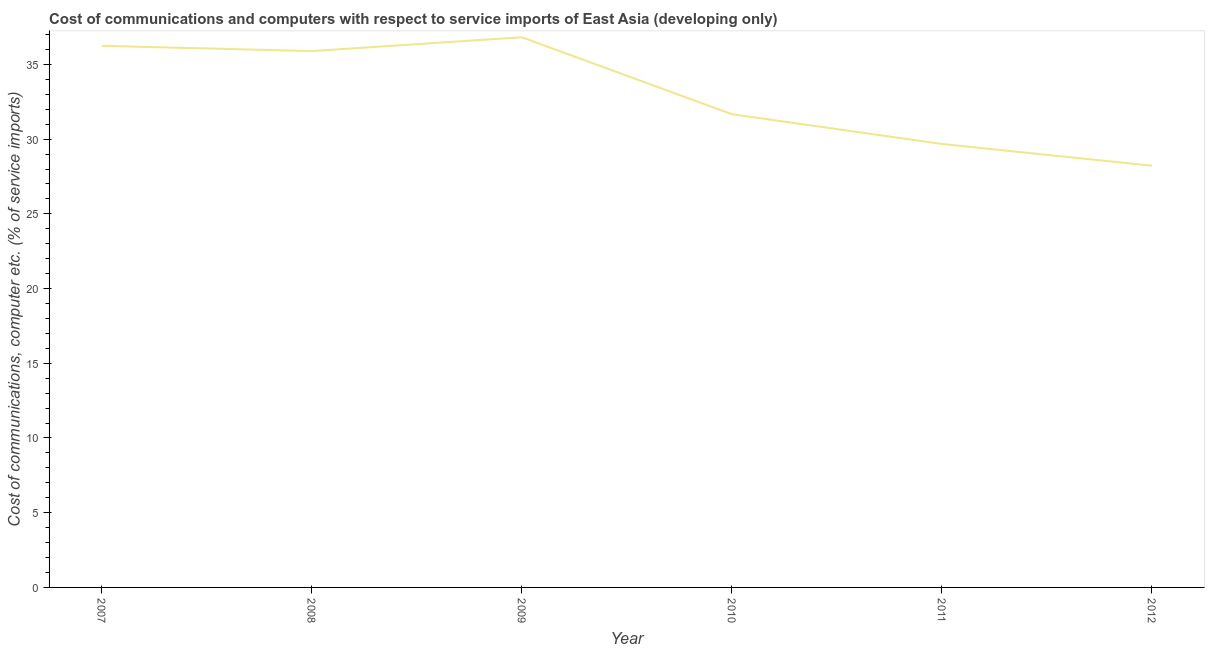What is the cost of communications and computer in 2008?
Ensure brevity in your answer.  35.89. Across all years, what is the maximum cost of communications and computer?
Offer a very short reply. 36.82. Across all years, what is the minimum cost of communications and computer?
Your response must be concise. 28.22. In which year was the cost of communications and computer maximum?
Your response must be concise. 2009. What is the sum of the cost of communications and computer?
Your response must be concise. 198.52. What is the difference between the cost of communications and computer in 2008 and 2012?
Keep it short and to the point. 7.67. What is the average cost of communications and computer per year?
Offer a very short reply. 33.09. What is the median cost of communications and computer?
Give a very brief answer. 33.78. Do a majority of the years between 2010 and 2008 (inclusive) have cost of communications and computer greater than 34 %?
Offer a very short reply. No. What is the ratio of the cost of communications and computer in 2009 to that in 2010?
Ensure brevity in your answer.  1.16. Is the cost of communications and computer in 2009 less than that in 2012?
Your answer should be very brief. No. What is the difference between the highest and the second highest cost of communications and computer?
Make the answer very short. 0.57. What is the difference between the highest and the lowest cost of communications and computer?
Your answer should be very brief. 8.6. How many years are there in the graph?
Ensure brevity in your answer.  6. What is the difference between two consecutive major ticks on the Y-axis?
Keep it short and to the point. 5. Are the values on the major ticks of Y-axis written in scientific E-notation?
Offer a terse response. No. Does the graph contain any zero values?
Offer a terse response. No. Does the graph contain grids?
Offer a terse response. No. What is the title of the graph?
Offer a very short reply. Cost of communications and computers with respect to service imports of East Asia (developing only). What is the label or title of the X-axis?
Your answer should be very brief. Year. What is the label or title of the Y-axis?
Make the answer very short. Cost of communications, computer etc. (% of service imports). What is the Cost of communications, computer etc. (% of service imports) of 2007?
Offer a very short reply. 36.24. What is the Cost of communications, computer etc. (% of service imports) in 2008?
Provide a succinct answer. 35.89. What is the Cost of communications, computer etc. (% of service imports) in 2009?
Offer a terse response. 36.82. What is the Cost of communications, computer etc. (% of service imports) in 2010?
Your answer should be very brief. 31.67. What is the Cost of communications, computer etc. (% of service imports) of 2011?
Offer a terse response. 29.67. What is the Cost of communications, computer etc. (% of service imports) in 2012?
Offer a terse response. 28.22. What is the difference between the Cost of communications, computer etc. (% of service imports) in 2007 and 2008?
Provide a succinct answer. 0.35. What is the difference between the Cost of communications, computer etc. (% of service imports) in 2007 and 2009?
Give a very brief answer. -0.57. What is the difference between the Cost of communications, computer etc. (% of service imports) in 2007 and 2010?
Give a very brief answer. 4.58. What is the difference between the Cost of communications, computer etc. (% of service imports) in 2007 and 2011?
Provide a succinct answer. 6.57. What is the difference between the Cost of communications, computer etc. (% of service imports) in 2007 and 2012?
Your answer should be very brief. 8.02. What is the difference between the Cost of communications, computer etc. (% of service imports) in 2008 and 2009?
Make the answer very short. -0.93. What is the difference between the Cost of communications, computer etc. (% of service imports) in 2008 and 2010?
Your answer should be compact. 4.22. What is the difference between the Cost of communications, computer etc. (% of service imports) in 2008 and 2011?
Give a very brief answer. 6.22. What is the difference between the Cost of communications, computer etc. (% of service imports) in 2008 and 2012?
Your answer should be very brief. 7.67. What is the difference between the Cost of communications, computer etc. (% of service imports) in 2009 and 2010?
Make the answer very short. 5.15. What is the difference between the Cost of communications, computer etc. (% of service imports) in 2009 and 2011?
Your answer should be compact. 7.14. What is the difference between the Cost of communications, computer etc. (% of service imports) in 2009 and 2012?
Offer a very short reply. 8.6. What is the difference between the Cost of communications, computer etc. (% of service imports) in 2010 and 2011?
Offer a terse response. 1.99. What is the difference between the Cost of communications, computer etc. (% of service imports) in 2010 and 2012?
Give a very brief answer. 3.45. What is the difference between the Cost of communications, computer etc. (% of service imports) in 2011 and 2012?
Provide a succinct answer. 1.45. What is the ratio of the Cost of communications, computer etc. (% of service imports) in 2007 to that in 2010?
Offer a terse response. 1.14. What is the ratio of the Cost of communications, computer etc. (% of service imports) in 2007 to that in 2011?
Your answer should be very brief. 1.22. What is the ratio of the Cost of communications, computer etc. (% of service imports) in 2007 to that in 2012?
Provide a short and direct response. 1.28. What is the ratio of the Cost of communications, computer etc. (% of service imports) in 2008 to that in 2009?
Keep it short and to the point. 0.97. What is the ratio of the Cost of communications, computer etc. (% of service imports) in 2008 to that in 2010?
Your answer should be compact. 1.13. What is the ratio of the Cost of communications, computer etc. (% of service imports) in 2008 to that in 2011?
Give a very brief answer. 1.21. What is the ratio of the Cost of communications, computer etc. (% of service imports) in 2008 to that in 2012?
Offer a very short reply. 1.27. What is the ratio of the Cost of communications, computer etc. (% of service imports) in 2009 to that in 2010?
Offer a very short reply. 1.16. What is the ratio of the Cost of communications, computer etc. (% of service imports) in 2009 to that in 2011?
Make the answer very short. 1.24. What is the ratio of the Cost of communications, computer etc. (% of service imports) in 2009 to that in 2012?
Give a very brief answer. 1.3. What is the ratio of the Cost of communications, computer etc. (% of service imports) in 2010 to that in 2011?
Provide a succinct answer. 1.07. What is the ratio of the Cost of communications, computer etc. (% of service imports) in 2010 to that in 2012?
Ensure brevity in your answer.  1.12. What is the ratio of the Cost of communications, computer etc. (% of service imports) in 2011 to that in 2012?
Give a very brief answer. 1.05. 